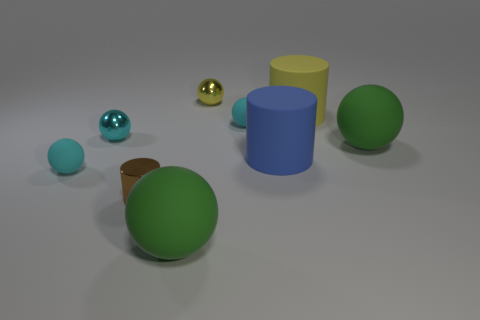Subtract all cyan cylinders. How many cyan balls are left? 3 Subtract all yellow spheres. How many spheres are left? 5 Subtract all small cyan metallic spheres. How many spheres are left? 5 Subtract all red spheres. Subtract all brown blocks. How many spheres are left? 6 Subtract all spheres. How many objects are left? 3 Add 6 cylinders. How many cylinders are left? 9 Add 9 blue cylinders. How many blue cylinders exist? 10 Subtract 0 purple blocks. How many objects are left? 9 Subtract all green matte objects. Subtract all small cyan objects. How many objects are left? 4 